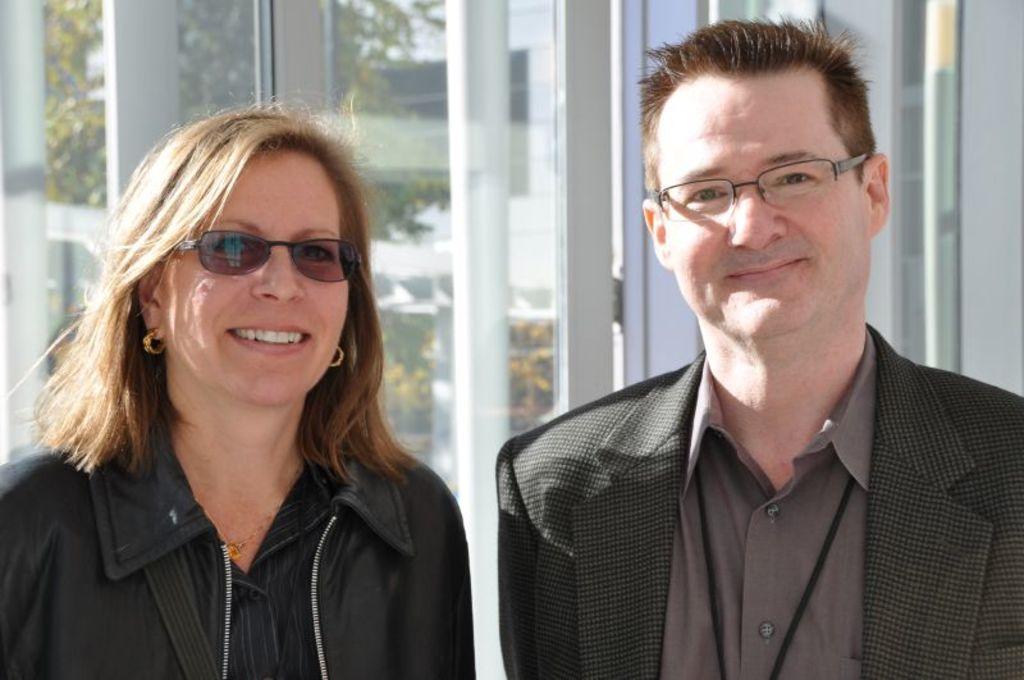Describe this image in one or two sentences. This picture might be taken from outside of the city and it is sunny. In this image, we can see two people man and woman wearing black color dress. In black ground, we can see glass window, trees. 